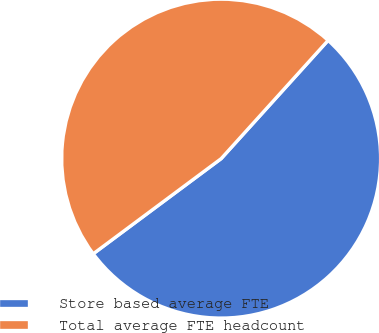<chart> <loc_0><loc_0><loc_500><loc_500><pie_chart><fcel>Store based average FTE<fcel>Total average FTE headcount<nl><fcel>53.12%<fcel>46.88%<nl></chart> 